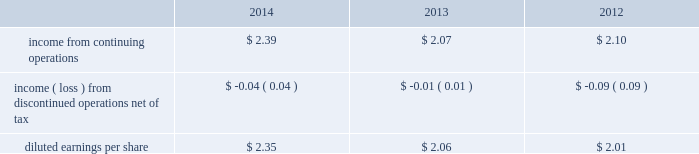From those currently anticipated and expressed in such forward-looking statements as a result of a number of factors , including those we discuss under 201crisk factors 201d and elsewhere in this form 10-k .
You should read 201crisk factors 201d and 201cforward-looking statements . 201d executive overview general american water works company , inc .
( herein referred to as 201camerican water 201d or the 201ccompany 201d ) is the largest investor-owned united states water and wastewater utility company , as measured both by operating revenues and population served .
Our approximately 6400 employees provide drinking water , wastewater and other water related services to an estimated 15 million people in 47 states and in one canadian province .
Our primary business involves the ownership of water and wastewater utilities that provide water and wastewater services to residential , commercial , industrial and other customers .
Our regulated businesses that provide these services are generally subject to economic regulation by state regulatory agencies in the states in which they operate .
The federal government and the states also regulate environmental , health and safety and water quality matters .
Our regulated businesses provide services in 16 states and serve approximately 3.2 million customers based on the number of active service connections to our water and wastewater networks .
We report the results of these businesses in our regulated businesses segment .
We also provide services that are not subject to economic regulation by state regulatory agencies .
We report the results of these businesses in our market-based operations segment .
In 2014 , we continued the execution of our strategic goals .
Our commitment to growth through investment in our regulated infrastructure and expansion of our regulated customer base and our market-based operations , combined with operational excellence led to continued improvement in regulated operating efficiency , improved performance of our market-based operations , and enabled us to provide increased value to our customers and investors .
During the year , we focused on growth , addressed regulatory lag , made more efficient use of capital and improved our regulated operation and maintenance ( 201co&m 201d ) efficiency ratio .
2014 financial results for the year ended december 31 , 2014 , we continued to increase net income , while making significant capital investment in our infrastructure and implementing operational efficiency improvements to keep customer rates affordable .
Highlights of our 2014 operating results compared to 2013 and 2012 include: .
Continuing operations income from continuing operations included 4 cents per diluted share of costs resulting from the freedom industries chemical spill in west virginia in 2014 and included 14 cents per diluted share in 2013 related to a tender offer .
Earnings from continuing operations , adjusted for these two items , increased 10% ( 10 % ) , or 22 cents per share , mainly due to favorable operating results from our regulated businesses segment due to higher revenues and lower operating expenses , partially offset by higher depreciation expenses .
Also contributing to the overall increase in income from continuing operations was lower interest expense in 2014 compared to the same period in 2013. .
By how much did income from continuing operations increase from 2012 to 2014? 
Computations: ((2.39 - 2.10) / 2.10)
Answer: 0.1381. From those currently anticipated and expressed in such forward-looking statements as a result of a number of factors , including those we discuss under 201crisk factors 201d and elsewhere in this form 10-k .
You should read 201crisk factors 201d and 201cforward-looking statements . 201d executive overview general american water works company , inc .
( herein referred to as 201camerican water 201d or the 201ccompany 201d ) is the largest investor-owned united states water and wastewater utility company , as measured both by operating revenues and population served .
Our approximately 6400 employees provide drinking water , wastewater and other water related services to an estimated 15 million people in 47 states and in one canadian province .
Our primary business involves the ownership of water and wastewater utilities that provide water and wastewater services to residential , commercial , industrial and other customers .
Our regulated businesses that provide these services are generally subject to economic regulation by state regulatory agencies in the states in which they operate .
The federal government and the states also regulate environmental , health and safety and water quality matters .
Our regulated businesses provide services in 16 states and serve approximately 3.2 million customers based on the number of active service connections to our water and wastewater networks .
We report the results of these businesses in our regulated businesses segment .
We also provide services that are not subject to economic regulation by state regulatory agencies .
We report the results of these businesses in our market-based operations segment .
In 2014 , we continued the execution of our strategic goals .
Our commitment to growth through investment in our regulated infrastructure and expansion of our regulated customer base and our market-based operations , combined with operational excellence led to continued improvement in regulated operating efficiency , improved performance of our market-based operations , and enabled us to provide increased value to our customers and investors .
During the year , we focused on growth , addressed regulatory lag , made more efficient use of capital and improved our regulated operation and maintenance ( 201co&m 201d ) efficiency ratio .
2014 financial results for the year ended december 31 , 2014 , we continued to increase net income , while making significant capital investment in our infrastructure and implementing operational efficiency improvements to keep customer rates affordable .
Highlights of our 2014 operating results compared to 2013 and 2012 include: .
Continuing operations income from continuing operations included 4 cents per diluted share of costs resulting from the freedom industries chemical spill in west virginia in 2014 and included 14 cents per diluted share in 2013 related to a tender offer .
Earnings from continuing operations , adjusted for these two items , increased 10% ( 10 % ) , or 22 cents per share , mainly due to favorable operating results from our regulated businesses segment due to higher revenues and lower operating expenses , partially offset by higher depreciation expenses .
Also contributing to the overall increase in income from continuing operations was lower interest expense in 2014 compared to the same period in 2013. .
What was the growth rate in diluted earnings per share from 2013 to 2014? 
Rationale: the earnings growth rate is the change in earnings from year to year divided by the starting year ( ( 2.39-2.09 ) /2.09 ) *100?
Computations: (2.35 - 2.06)
Answer: 0.29. 